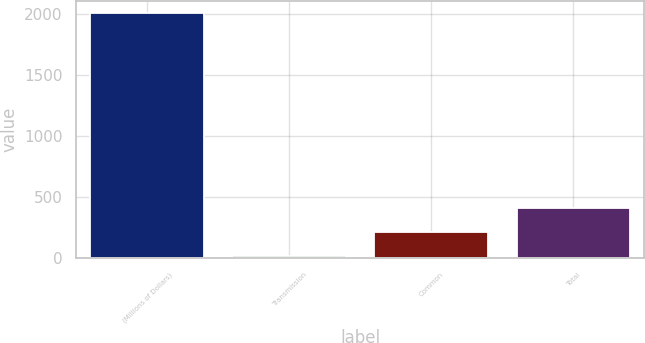Convert chart to OTSL. <chart><loc_0><loc_0><loc_500><loc_500><bar_chart><fcel>(Millions of Dollars)<fcel>Transmission<fcel>Common<fcel>Total<nl><fcel>2004<fcel>16<fcel>214.8<fcel>413.6<nl></chart> 